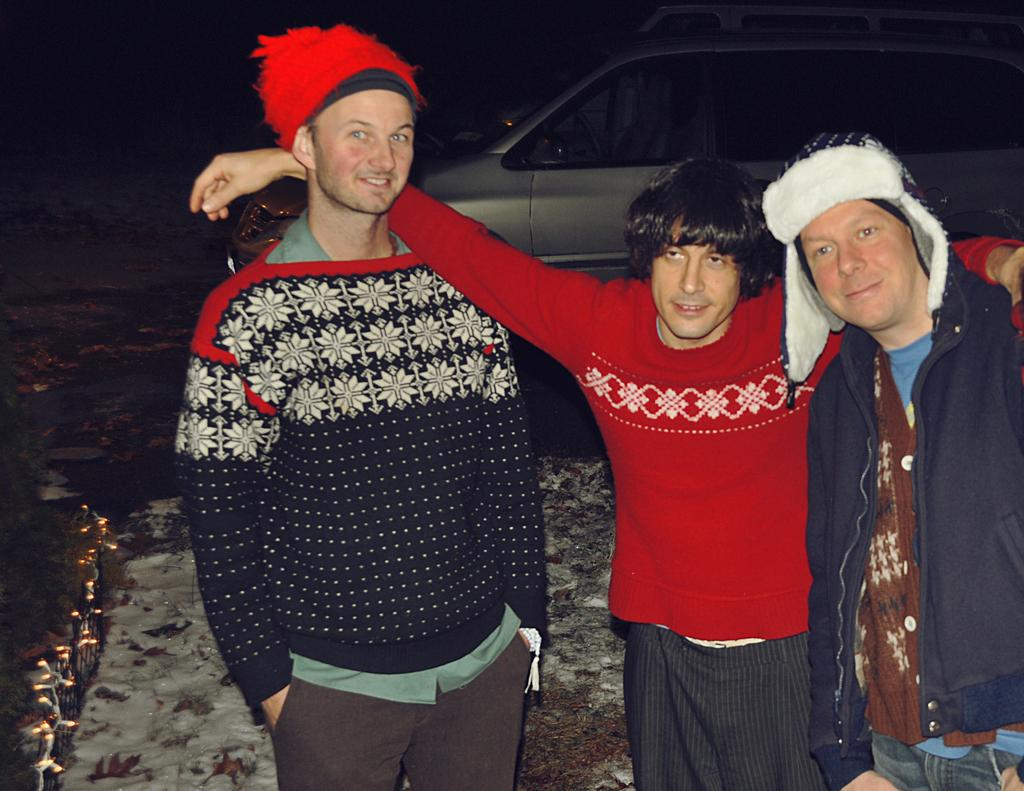How many people are in the image? There are three people in the image. Where are the people located in the image? The people are standing on the road. What can be seen behind the people in the image? There are cars parked behind the people. What type of rat can be seen in the middle of the image? There is no rat present in the image. 